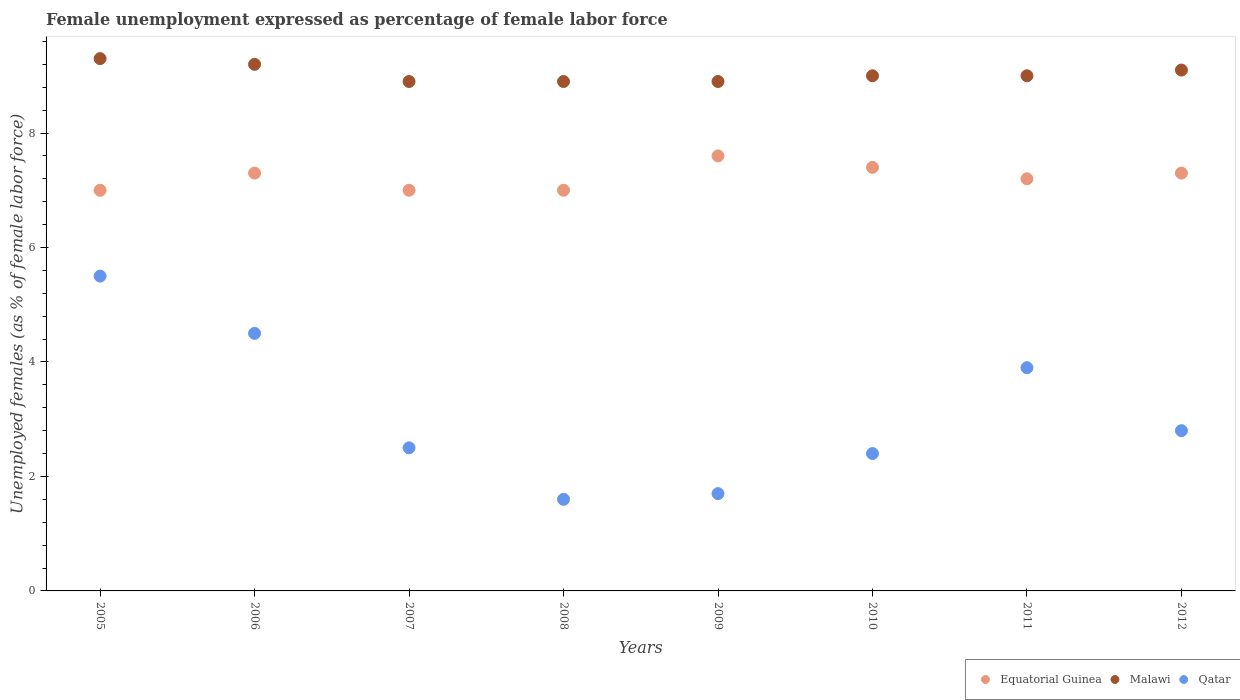How many different coloured dotlines are there?
Your answer should be compact. 3. What is the unemployment in females in in Malawi in 2011?
Keep it short and to the point. 9. Across all years, what is the maximum unemployment in females in in Malawi?
Keep it short and to the point. 9.3. Across all years, what is the minimum unemployment in females in in Malawi?
Make the answer very short. 8.9. In which year was the unemployment in females in in Malawi maximum?
Offer a terse response. 2005. What is the total unemployment in females in in Qatar in the graph?
Your answer should be compact. 24.9. What is the difference between the unemployment in females in in Equatorial Guinea in 2009 and that in 2011?
Offer a very short reply. 0.4. What is the difference between the unemployment in females in in Equatorial Guinea in 2007 and the unemployment in females in in Malawi in 2009?
Offer a very short reply. -1.9. What is the average unemployment in females in in Qatar per year?
Make the answer very short. 3.11. In the year 2010, what is the difference between the unemployment in females in in Equatorial Guinea and unemployment in females in in Qatar?
Your answer should be compact. 5. What is the ratio of the unemployment in females in in Qatar in 2006 to that in 2012?
Give a very brief answer. 1.61. Is the unemployment in females in in Malawi in 2005 less than that in 2010?
Your answer should be compact. No. Is the difference between the unemployment in females in in Equatorial Guinea in 2009 and 2010 greater than the difference between the unemployment in females in in Qatar in 2009 and 2010?
Provide a short and direct response. Yes. What is the difference between the highest and the second highest unemployment in females in in Equatorial Guinea?
Your response must be concise. 0.2. What is the difference between the highest and the lowest unemployment in females in in Equatorial Guinea?
Provide a succinct answer. 0.6. In how many years, is the unemployment in females in in Qatar greater than the average unemployment in females in in Qatar taken over all years?
Your answer should be compact. 3. Is it the case that in every year, the sum of the unemployment in females in in Equatorial Guinea and unemployment in females in in Qatar  is greater than the unemployment in females in in Malawi?
Provide a short and direct response. No. Does the unemployment in females in in Qatar monotonically increase over the years?
Provide a short and direct response. No. What is the difference between two consecutive major ticks on the Y-axis?
Provide a succinct answer. 2. Are the values on the major ticks of Y-axis written in scientific E-notation?
Offer a very short reply. No. How are the legend labels stacked?
Ensure brevity in your answer.  Horizontal. What is the title of the graph?
Offer a terse response. Female unemployment expressed as percentage of female labor force. Does "Ghana" appear as one of the legend labels in the graph?
Make the answer very short. No. What is the label or title of the Y-axis?
Your answer should be very brief. Unemployed females (as % of female labor force). What is the Unemployed females (as % of female labor force) in Malawi in 2005?
Give a very brief answer. 9.3. What is the Unemployed females (as % of female labor force) in Qatar in 2005?
Offer a terse response. 5.5. What is the Unemployed females (as % of female labor force) of Equatorial Guinea in 2006?
Offer a very short reply. 7.3. What is the Unemployed females (as % of female labor force) in Malawi in 2006?
Your answer should be very brief. 9.2. What is the Unemployed females (as % of female labor force) of Qatar in 2006?
Ensure brevity in your answer.  4.5. What is the Unemployed females (as % of female labor force) in Malawi in 2007?
Your response must be concise. 8.9. What is the Unemployed females (as % of female labor force) of Malawi in 2008?
Give a very brief answer. 8.9. What is the Unemployed females (as % of female labor force) in Qatar in 2008?
Keep it short and to the point. 1.6. What is the Unemployed females (as % of female labor force) in Equatorial Guinea in 2009?
Ensure brevity in your answer.  7.6. What is the Unemployed females (as % of female labor force) of Malawi in 2009?
Provide a succinct answer. 8.9. What is the Unemployed females (as % of female labor force) in Qatar in 2009?
Keep it short and to the point. 1.7. What is the Unemployed females (as % of female labor force) of Equatorial Guinea in 2010?
Your answer should be compact. 7.4. What is the Unemployed females (as % of female labor force) in Malawi in 2010?
Offer a terse response. 9. What is the Unemployed females (as % of female labor force) in Qatar in 2010?
Your response must be concise. 2.4. What is the Unemployed females (as % of female labor force) of Equatorial Guinea in 2011?
Provide a short and direct response. 7.2. What is the Unemployed females (as % of female labor force) in Qatar in 2011?
Make the answer very short. 3.9. What is the Unemployed females (as % of female labor force) of Equatorial Guinea in 2012?
Your answer should be very brief. 7.3. What is the Unemployed females (as % of female labor force) of Malawi in 2012?
Keep it short and to the point. 9.1. What is the Unemployed females (as % of female labor force) in Qatar in 2012?
Give a very brief answer. 2.8. Across all years, what is the maximum Unemployed females (as % of female labor force) of Equatorial Guinea?
Keep it short and to the point. 7.6. Across all years, what is the maximum Unemployed females (as % of female labor force) in Malawi?
Provide a short and direct response. 9.3. Across all years, what is the maximum Unemployed females (as % of female labor force) in Qatar?
Ensure brevity in your answer.  5.5. Across all years, what is the minimum Unemployed females (as % of female labor force) of Equatorial Guinea?
Provide a succinct answer. 7. Across all years, what is the minimum Unemployed females (as % of female labor force) of Malawi?
Ensure brevity in your answer.  8.9. Across all years, what is the minimum Unemployed females (as % of female labor force) of Qatar?
Provide a short and direct response. 1.6. What is the total Unemployed females (as % of female labor force) of Equatorial Guinea in the graph?
Make the answer very short. 57.8. What is the total Unemployed females (as % of female labor force) in Malawi in the graph?
Your answer should be very brief. 72.3. What is the total Unemployed females (as % of female labor force) of Qatar in the graph?
Ensure brevity in your answer.  24.9. What is the difference between the Unemployed females (as % of female labor force) of Equatorial Guinea in 2005 and that in 2006?
Your answer should be very brief. -0.3. What is the difference between the Unemployed females (as % of female labor force) in Equatorial Guinea in 2005 and that in 2007?
Your response must be concise. 0. What is the difference between the Unemployed females (as % of female labor force) of Malawi in 2005 and that in 2007?
Provide a short and direct response. 0.4. What is the difference between the Unemployed females (as % of female labor force) of Qatar in 2005 and that in 2007?
Your answer should be compact. 3. What is the difference between the Unemployed females (as % of female labor force) in Qatar in 2005 and that in 2009?
Offer a very short reply. 3.8. What is the difference between the Unemployed females (as % of female labor force) of Equatorial Guinea in 2005 and that in 2010?
Provide a succinct answer. -0.4. What is the difference between the Unemployed females (as % of female labor force) in Malawi in 2005 and that in 2010?
Provide a succinct answer. 0.3. What is the difference between the Unemployed females (as % of female labor force) in Malawi in 2005 and that in 2011?
Offer a terse response. 0.3. What is the difference between the Unemployed females (as % of female labor force) in Qatar in 2005 and that in 2011?
Give a very brief answer. 1.6. What is the difference between the Unemployed females (as % of female labor force) in Equatorial Guinea in 2005 and that in 2012?
Give a very brief answer. -0.3. What is the difference between the Unemployed females (as % of female labor force) of Malawi in 2005 and that in 2012?
Provide a succinct answer. 0.2. What is the difference between the Unemployed females (as % of female labor force) of Qatar in 2005 and that in 2012?
Your answer should be compact. 2.7. What is the difference between the Unemployed females (as % of female labor force) in Malawi in 2006 and that in 2008?
Your response must be concise. 0.3. What is the difference between the Unemployed females (as % of female labor force) in Qatar in 2006 and that in 2008?
Ensure brevity in your answer.  2.9. What is the difference between the Unemployed females (as % of female labor force) of Malawi in 2006 and that in 2009?
Offer a terse response. 0.3. What is the difference between the Unemployed females (as % of female labor force) in Equatorial Guinea in 2006 and that in 2010?
Make the answer very short. -0.1. What is the difference between the Unemployed females (as % of female labor force) of Qatar in 2006 and that in 2010?
Offer a very short reply. 2.1. What is the difference between the Unemployed females (as % of female labor force) of Equatorial Guinea in 2006 and that in 2011?
Offer a very short reply. 0.1. What is the difference between the Unemployed females (as % of female labor force) in Malawi in 2006 and that in 2011?
Provide a short and direct response. 0.2. What is the difference between the Unemployed females (as % of female labor force) in Equatorial Guinea in 2006 and that in 2012?
Your answer should be compact. 0. What is the difference between the Unemployed females (as % of female labor force) in Malawi in 2006 and that in 2012?
Offer a very short reply. 0.1. What is the difference between the Unemployed females (as % of female labor force) in Qatar in 2006 and that in 2012?
Provide a short and direct response. 1.7. What is the difference between the Unemployed females (as % of female labor force) of Equatorial Guinea in 2007 and that in 2008?
Offer a very short reply. 0. What is the difference between the Unemployed females (as % of female labor force) in Malawi in 2007 and that in 2009?
Offer a very short reply. 0. What is the difference between the Unemployed females (as % of female labor force) of Qatar in 2007 and that in 2009?
Your answer should be compact. 0.8. What is the difference between the Unemployed females (as % of female labor force) in Equatorial Guinea in 2007 and that in 2010?
Provide a short and direct response. -0.4. What is the difference between the Unemployed females (as % of female labor force) of Malawi in 2007 and that in 2010?
Your answer should be compact. -0.1. What is the difference between the Unemployed females (as % of female labor force) in Qatar in 2007 and that in 2010?
Keep it short and to the point. 0.1. What is the difference between the Unemployed females (as % of female labor force) in Qatar in 2008 and that in 2009?
Provide a succinct answer. -0.1. What is the difference between the Unemployed females (as % of female labor force) of Equatorial Guinea in 2008 and that in 2010?
Make the answer very short. -0.4. What is the difference between the Unemployed females (as % of female labor force) of Malawi in 2008 and that in 2010?
Keep it short and to the point. -0.1. What is the difference between the Unemployed females (as % of female labor force) in Qatar in 2008 and that in 2010?
Provide a succinct answer. -0.8. What is the difference between the Unemployed females (as % of female labor force) in Equatorial Guinea in 2008 and that in 2011?
Ensure brevity in your answer.  -0.2. What is the difference between the Unemployed females (as % of female labor force) in Equatorial Guinea in 2008 and that in 2012?
Your answer should be compact. -0.3. What is the difference between the Unemployed females (as % of female labor force) of Malawi in 2008 and that in 2012?
Offer a terse response. -0.2. What is the difference between the Unemployed females (as % of female labor force) in Qatar in 2008 and that in 2012?
Offer a terse response. -1.2. What is the difference between the Unemployed females (as % of female labor force) in Malawi in 2009 and that in 2011?
Your response must be concise. -0.1. What is the difference between the Unemployed females (as % of female labor force) of Equatorial Guinea in 2009 and that in 2012?
Provide a succinct answer. 0.3. What is the difference between the Unemployed females (as % of female labor force) in Malawi in 2009 and that in 2012?
Give a very brief answer. -0.2. What is the difference between the Unemployed females (as % of female labor force) in Qatar in 2009 and that in 2012?
Give a very brief answer. -1.1. What is the difference between the Unemployed females (as % of female labor force) in Equatorial Guinea in 2010 and that in 2011?
Offer a very short reply. 0.2. What is the difference between the Unemployed females (as % of female labor force) of Equatorial Guinea in 2010 and that in 2012?
Keep it short and to the point. 0.1. What is the difference between the Unemployed females (as % of female labor force) in Qatar in 2010 and that in 2012?
Your response must be concise. -0.4. What is the difference between the Unemployed females (as % of female labor force) of Equatorial Guinea in 2011 and that in 2012?
Provide a succinct answer. -0.1. What is the difference between the Unemployed females (as % of female labor force) in Malawi in 2005 and the Unemployed females (as % of female labor force) in Qatar in 2006?
Your answer should be compact. 4.8. What is the difference between the Unemployed females (as % of female labor force) of Equatorial Guinea in 2005 and the Unemployed females (as % of female labor force) of Malawi in 2007?
Give a very brief answer. -1.9. What is the difference between the Unemployed females (as % of female labor force) of Malawi in 2005 and the Unemployed females (as % of female labor force) of Qatar in 2007?
Your response must be concise. 6.8. What is the difference between the Unemployed females (as % of female labor force) of Equatorial Guinea in 2005 and the Unemployed females (as % of female labor force) of Qatar in 2008?
Keep it short and to the point. 5.4. What is the difference between the Unemployed females (as % of female labor force) of Malawi in 2005 and the Unemployed females (as % of female labor force) of Qatar in 2008?
Provide a succinct answer. 7.7. What is the difference between the Unemployed females (as % of female labor force) in Malawi in 2005 and the Unemployed females (as % of female labor force) in Qatar in 2009?
Provide a short and direct response. 7.6. What is the difference between the Unemployed females (as % of female labor force) of Equatorial Guinea in 2005 and the Unemployed females (as % of female labor force) of Qatar in 2010?
Ensure brevity in your answer.  4.6. What is the difference between the Unemployed females (as % of female labor force) in Equatorial Guinea in 2005 and the Unemployed females (as % of female labor force) in Qatar in 2011?
Your answer should be very brief. 3.1. What is the difference between the Unemployed females (as % of female labor force) of Malawi in 2005 and the Unemployed females (as % of female labor force) of Qatar in 2011?
Give a very brief answer. 5.4. What is the difference between the Unemployed females (as % of female labor force) of Equatorial Guinea in 2005 and the Unemployed females (as % of female labor force) of Qatar in 2012?
Keep it short and to the point. 4.2. What is the difference between the Unemployed females (as % of female labor force) of Malawi in 2006 and the Unemployed females (as % of female labor force) of Qatar in 2007?
Give a very brief answer. 6.7. What is the difference between the Unemployed females (as % of female labor force) in Equatorial Guinea in 2006 and the Unemployed females (as % of female labor force) in Malawi in 2009?
Ensure brevity in your answer.  -1.6. What is the difference between the Unemployed females (as % of female labor force) of Equatorial Guinea in 2006 and the Unemployed females (as % of female labor force) of Qatar in 2009?
Your response must be concise. 5.6. What is the difference between the Unemployed females (as % of female labor force) of Equatorial Guinea in 2006 and the Unemployed females (as % of female labor force) of Malawi in 2010?
Your answer should be very brief. -1.7. What is the difference between the Unemployed females (as % of female labor force) in Equatorial Guinea in 2006 and the Unemployed females (as % of female labor force) in Qatar in 2010?
Provide a succinct answer. 4.9. What is the difference between the Unemployed females (as % of female labor force) of Malawi in 2006 and the Unemployed females (as % of female labor force) of Qatar in 2010?
Provide a succinct answer. 6.8. What is the difference between the Unemployed females (as % of female labor force) of Equatorial Guinea in 2006 and the Unemployed females (as % of female labor force) of Qatar in 2011?
Keep it short and to the point. 3.4. What is the difference between the Unemployed females (as % of female labor force) of Equatorial Guinea in 2006 and the Unemployed females (as % of female labor force) of Qatar in 2012?
Provide a succinct answer. 4.5. What is the difference between the Unemployed females (as % of female labor force) in Malawi in 2006 and the Unemployed females (as % of female labor force) in Qatar in 2012?
Provide a short and direct response. 6.4. What is the difference between the Unemployed females (as % of female labor force) of Equatorial Guinea in 2007 and the Unemployed females (as % of female labor force) of Qatar in 2008?
Your answer should be compact. 5.4. What is the difference between the Unemployed females (as % of female labor force) in Malawi in 2007 and the Unemployed females (as % of female labor force) in Qatar in 2009?
Keep it short and to the point. 7.2. What is the difference between the Unemployed females (as % of female labor force) of Equatorial Guinea in 2007 and the Unemployed females (as % of female labor force) of Malawi in 2010?
Give a very brief answer. -2. What is the difference between the Unemployed females (as % of female labor force) in Equatorial Guinea in 2007 and the Unemployed females (as % of female labor force) in Qatar in 2010?
Ensure brevity in your answer.  4.6. What is the difference between the Unemployed females (as % of female labor force) in Malawi in 2007 and the Unemployed females (as % of female labor force) in Qatar in 2010?
Your answer should be very brief. 6.5. What is the difference between the Unemployed females (as % of female labor force) in Equatorial Guinea in 2007 and the Unemployed females (as % of female labor force) in Malawi in 2011?
Make the answer very short. -2. What is the difference between the Unemployed females (as % of female labor force) in Equatorial Guinea in 2007 and the Unemployed females (as % of female labor force) in Qatar in 2011?
Give a very brief answer. 3.1. What is the difference between the Unemployed females (as % of female labor force) of Malawi in 2007 and the Unemployed females (as % of female labor force) of Qatar in 2011?
Offer a terse response. 5. What is the difference between the Unemployed females (as % of female labor force) in Equatorial Guinea in 2008 and the Unemployed females (as % of female labor force) in Malawi in 2009?
Your answer should be very brief. -1.9. What is the difference between the Unemployed females (as % of female labor force) in Equatorial Guinea in 2008 and the Unemployed females (as % of female labor force) in Qatar in 2009?
Your answer should be very brief. 5.3. What is the difference between the Unemployed females (as % of female labor force) of Malawi in 2008 and the Unemployed females (as % of female labor force) of Qatar in 2009?
Your answer should be very brief. 7.2. What is the difference between the Unemployed females (as % of female labor force) of Equatorial Guinea in 2008 and the Unemployed females (as % of female labor force) of Malawi in 2010?
Your answer should be compact. -2. What is the difference between the Unemployed females (as % of female labor force) of Equatorial Guinea in 2008 and the Unemployed females (as % of female labor force) of Qatar in 2010?
Your answer should be compact. 4.6. What is the difference between the Unemployed females (as % of female labor force) of Equatorial Guinea in 2008 and the Unemployed females (as % of female labor force) of Malawi in 2012?
Offer a terse response. -2.1. What is the difference between the Unemployed females (as % of female labor force) of Malawi in 2008 and the Unemployed females (as % of female labor force) of Qatar in 2012?
Ensure brevity in your answer.  6.1. What is the difference between the Unemployed females (as % of female labor force) of Equatorial Guinea in 2009 and the Unemployed females (as % of female labor force) of Malawi in 2010?
Your answer should be very brief. -1.4. What is the difference between the Unemployed females (as % of female labor force) of Equatorial Guinea in 2009 and the Unemployed females (as % of female labor force) of Qatar in 2010?
Give a very brief answer. 5.2. What is the difference between the Unemployed females (as % of female labor force) in Malawi in 2009 and the Unemployed females (as % of female labor force) in Qatar in 2010?
Provide a short and direct response. 6.5. What is the difference between the Unemployed females (as % of female labor force) of Equatorial Guinea in 2009 and the Unemployed females (as % of female labor force) of Malawi in 2011?
Give a very brief answer. -1.4. What is the difference between the Unemployed females (as % of female labor force) in Equatorial Guinea in 2009 and the Unemployed females (as % of female labor force) in Qatar in 2011?
Make the answer very short. 3.7. What is the difference between the Unemployed females (as % of female labor force) of Equatorial Guinea in 2009 and the Unemployed females (as % of female labor force) of Malawi in 2012?
Give a very brief answer. -1.5. What is the difference between the Unemployed females (as % of female labor force) of Malawi in 2010 and the Unemployed females (as % of female labor force) of Qatar in 2011?
Give a very brief answer. 5.1. What is the difference between the Unemployed females (as % of female labor force) of Equatorial Guinea in 2010 and the Unemployed females (as % of female labor force) of Malawi in 2012?
Ensure brevity in your answer.  -1.7. What is the difference between the Unemployed females (as % of female labor force) in Malawi in 2010 and the Unemployed females (as % of female labor force) in Qatar in 2012?
Ensure brevity in your answer.  6.2. What is the difference between the Unemployed females (as % of female labor force) of Equatorial Guinea in 2011 and the Unemployed females (as % of female labor force) of Malawi in 2012?
Provide a succinct answer. -1.9. What is the difference between the Unemployed females (as % of female labor force) of Malawi in 2011 and the Unemployed females (as % of female labor force) of Qatar in 2012?
Provide a succinct answer. 6.2. What is the average Unemployed females (as % of female labor force) in Equatorial Guinea per year?
Your answer should be compact. 7.22. What is the average Unemployed females (as % of female labor force) of Malawi per year?
Ensure brevity in your answer.  9.04. What is the average Unemployed females (as % of female labor force) of Qatar per year?
Provide a succinct answer. 3.11. In the year 2005, what is the difference between the Unemployed females (as % of female labor force) of Equatorial Guinea and Unemployed females (as % of female labor force) of Malawi?
Offer a very short reply. -2.3. In the year 2007, what is the difference between the Unemployed females (as % of female labor force) of Equatorial Guinea and Unemployed females (as % of female labor force) of Malawi?
Provide a succinct answer. -1.9. In the year 2008, what is the difference between the Unemployed females (as % of female labor force) in Malawi and Unemployed females (as % of female labor force) in Qatar?
Offer a terse response. 7.3. In the year 2009, what is the difference between the Unemployed females (as % of female labor force) in Malawi and Unemployed females (as % of female labor force) in Qatar?
Make the answer very short. 7.2. In the year 2010, what is the difference between the Unemployed females (as % of female labor force) of Equatorial Guinea and Unemployed females (as % of female labor force) of Qatar?
Provide a succinct answer. 5. In the year 2010, what is the difference between the Unemployed females (as % of female labor force) in Malawi and Unemployed females (as % of female labor force) in Qatar?
Give a very brief answer. 6.6. In the year 2011, what is the difference between the Unemployed females (as % of female labor force) of Malawi and Unemployed females (as % of female labor force) of Qatar?
Provide a short and direct response. 5.1. In the year 2012, what is the difference between the Unemployed females (as % of female labor force) in Equatorial Guinea and Unemployed females (as % of female labor force) in Malawi?
Ensure brevity in your answer.  -1.8. What is the ratio of the Unemployed females (as % of female labor force) in Equatorial Guinea in 2005 to that in 2006?
Keep it short and to the point. 0.96. What is the ratio of the Unemployed females (as % of female labor force) of Malawi in 2005 to that in 2006?
Make the answer very short. 1.01. What is the ratio of the Unemployed females (as % of female labor force) in Qatar in 2005 to that in 2006?
Provide a short and direct response. 1.22. What is the ratio of the Unemployed females (as % of female labor force) in Equatorial Guinea in 2005 to that in 2007?
Your answer should be very brief. 1. What is the ratio of the Unemployed females (as % of female labor force) of Malawi in 2005 to that in 2007?
Give a very brief answer. 1.04. What is the ratio of the Unemployed females (as % of female labor force) of Equatorial Guinea in 2005 to that in 2008?
Offer a terse response. 1. What is the ratio of the Unemployed females (as % of female labor force) in Malawi in 2005 to that in 2008?
Your response must be concise. 1.04. What is the ratio of the Unemployed females (as % of female labor force) in Qatar in 2005 to that in 2008?
Ensure brevity in your answer.  3.44. What is the ratio of the Unemployed females (as % of female labor force) in Equatorial Guinea in 2005 to that in 2009?
Offer a terse response. 0.92. What is the ratio of the Unemployed females (as % of female labor force) in Malawi in 2005 to that in 2009?
Keep it short and to the point. 1.04. What is the ratio of the Unemployed females (as % of female labor force) of Qatar in 2005 to that in 2009?
Your answer should be compact. 3.24. What is the ratio of the Unemployed females (as % of female labor force) in Equatorial Guinea in 2005 to that in 2010?
Ensure brevity in your answer.  0.95. What is the ratio of the Unemployed females (as % of female labor force) in Qatar in 2005 to that in 2010?
Your response must be concise. 2.29. What is the ratio of the Unemployed females (as % of female labor force) of Equatorial Guinea in 2005 to that in 2011?
Ensure brevity in your answer.  0.97. What is the ratio of the Unemployed females (as % of female labor force) of Malawi in 2005 to that in 2011?
Make the answer very short. 1.03. What is the ratio of the Unemployed females (as % of female labor force) in Qatar in 2005 to that in 2011?
Offer a terse response. 1.41. What is the ratio of the Unemployed females (as % of female labor force) in Equatorial Guinea in 2005 to that in 2012?
Make the answer very short. 0.96. What is the ratio of the Unemployed females (as % of female labor force) in Qatar in 2005 to that in 2012?
Give a very brief answer. 1.96. What is the ratio of the Unemployed females (as % of female labor force) in Equatorial Guinea in 2006 to that in 2007?
Provide a short and direct response. 1.04. What is the ratio of the Unemployed females (as % of female labor force) in Malawi in 2006 to that in 2007?
Make the answer very short. 1.03. What is the ratio of the Unemployed females (as % of female labor force) of Qatar in 2006 to that in 2007?
Ensure brevity in your answer.  1.8. What is the ratio of the Unemployed females (as % of female labor force) in Equatorial Guinea in 2006 to that in 2008?
Give a very brief answer. 1.04. What is the ratio of the Unemployed females (as % of female labor force) in Malawi in 2006 to that in 2008?
Provide a succinct answer. 1.03. What is the ratio of the Unemployed females (as % of female labor force) of Qatar in 2006 to that in 2008?
Provide a succinct answer. 2.81. What is the ratio of the Unemployed females (as % of female labor force) of Equatorial Guinea in 2006 to that in 2009?
Make the answer very short. 0.96. What is the ratio of the Unemployed females (as % of female labor force) in Malawi in 2006 to that in 2009?
Make the answer very short. 1.03. What is the ratio of the Unemployed females (as % of female labor force) of Qatar in 2006 to that in 2009?
Offer a very short reply. 2.65. What is the ratio of the Unemployed females (as % of female labor force) of Equatorial Guinea in 2006 to that in 2010?
Your response must be concise. 0.99. What is the ratio of the Unemployed females (as % of female labor force) of Malawi in 2006 to that in 2010?
Provide a succinct answer. 1.02. What is the ratio of the Unemployed females (as % of female labor force) in Qatar in 2006 to that in 2010?
Your response must be concise. 1.88. What is the ratio of the Unemployed females (as % of female labor force) of Equatorial Guinea in 2006 to that in 2011?
Your answer should be compact. 1.01. What is the ratio of the Unemployed females (as % of female labor force) in Malawi in 2006 to that in 2011?
Make the answer very short. 1.02. What is the ratio of the Unemployed females (as % of female labor force) in Qatar in 2006 to that in 2011?
Provide a succinct answer. 1.15. What is the ratio of the Unemployed females (as % of female labor force) in Equatorial Guinea in 2006 to that in 2012?
Provide a succinct answer. 1. What is the ratio of the Unemployed females (as % of female labor force) in Qatar in 2006 to that in 2012?
Your answer should be compact. 1.61. What is the ratio of the Unemployed females (as % of female labor force) of Equatorial Guinea in 2007 to that in 2008?
Your response must be concise. 1. What is the ratio of the Unemployed females (as % of female labor force) of Qatar in 2007 to that in 2008?
Ensure brevity in your answer.  1.56. What is the ratio of the Unemployed females (as % of female labor force) of Equatorial Guinea in 2007 to that in 2009?
Offer a terse response. 0.92. What is the ratio of the Unemployed females (as % of female labor force) in Qatar in 2007 to that in 2009?
Ensure brevity in your answer.  1.47. What is the ratio of the Unemployed females (as % of female labor force) of Equatorial Guinea in 2007 to that in 2010?
Offer a terse response. 0.95. What is the ratio of the Unemployed females (as % of female labor force) in Malawi in 2007 to that in 2010?
Provide a succinct answer. 0.99. What is the ratio of the Unemployed females (as % of female labor force) of Qatar in 2007 to that in 2010?
Make the answer very short. 1.04. What is the ratio of the Unemployed females (as % of female labor force) of Equatorial Guinea in 2007 to that in 2011?
Provide a succinct answer. 0.97. What is the ratio of the Unemployed females (as % of female labor force) in Malawi in 2007 to that in 2011?
Your answer should be very brief. 0.99. What is the ratio of the Unemployed females (as % of female labor force) of Qatar in 2007 to that in 2011?
Your answer should be very brief. 0.64. What is the ratio of the Unemployed females (as % of female labor force) in Equatorial Guinea in 2007 to that in 2012?
Give a very brief answer. 0.96. What is the ratio of the Unemployed females (as % of female labor force) in Malawi in 2007 to that in 2012?
Offer a very short reply. 0.98. What is the ratio of the Unemployed females (as % of female labor force) in Qatar in 2007 to that in 2012?
Your answer should be very brief. 0.89. What is the ratio of the Unemployed females (as % of female labor force) of Equatorial Guinea in 2008 to that in 2009?
Keep it short and to the point. 0.92. What is the ratio of the Unemployed females (as % of female labor force) in Qatar in 2008 to that in 2009?
Give a very brief answer. 0.94. What is the ratio of the Unemployed females (as % of female labor force) in Equatorial Guinea in 2008 to that in 2010?
Provide a succinct answer. 0.95. What is the ratio of the Unemployed females (as % of female labor force) of Malawi in 2008 to that in 2010?
Make the answer very short. 0.99. What is the ratio of the Unemployed females (as % of female labor force) of Qatar in 2008 to that in 2010?
Provide a short and direct response. 0.67. What is the ratio of the Unemployed females (as % of female labor force) in Equatorial Guinea in 2008 to that in 2011?
Offer a very short reply. 0.97. What is the ratio of the Unemployed females (as % of female labor force) in Malawi in 2008 to that in 2011?
Give a very brief answer. 0.99. What is the ratio of the Unemployed females (as % of female labor force) in Qatar in 2008 to that in 2011?
Your answer should be very brief. 0.41. What is the ratio of the Unemployed females (as % of female labor force) in Equatorial Guinea in 2008 to that in 2012?
Keep it short and to the point. 0.96. What is the ratio of the Unemployed females (as % of female labor force) in Malawi in 2008 to that in 2012?
Your response must be concise. 0.98. What is the ratio of the Unemployed females (as % of female labor force) in Equatorial Guinea in 2009 to that in 2010?
Give a very brief answer. 1.03. What is the ratio of the Unemployed females (as % of female labor force) in Malawi in 2009 to that in 2010?
Your answer should be compact. 0.99. What is the ratio of the Unemployed females (as % of female labor force) in Qatar in 2009 to that in 2010?
Your response must be concise. 0.71. What is the ratio of the Unemployed females (as % of female labor force) in Equatorial Guinea in 2009 to that in 2011?
Make the answer very short. 1.06. What is the ratio of the Unemployed females (as % of female labor force) of Malawi in 2009 to that in 2011?
Your response must be concise. 0.99. What is the ratio of the Unemployed females (as % of female labor force) in Qatar in 2009 to that in 2011?
Your answer should be very brief. 0.44. What is the ratio of the Unemployed females (as % of female labor force) of Equatorial Guinea in 2009 to that in 2012?
Your response must be concise. 1.04. What is the ratio of the Unemployed females (as % of female labor force) in Malawi in 2009 to that in 2012?
Your response must be concise. 0.98. What is the ratio of the Unemployed females (as % of female labor force) of Qatar in 2009 to that in 2012?
Your answer should be compact. 0.61. What is the ratio of the Unemployed females (as % of female labor force) in Equatorial Guinea in 2010 to that in 2011?
Offer a terse response. 1.03. What is the ratio of the Unemployed females (as % of female labor force) in Qatar in 2010 to that in 2011?
Make the answer very short. 0.62. What is the ratio of the Unemployed females (as % of female labor force) in Equatorial Guinea in 2010 to that in 2012?
Ensure brevity in your answer.  1.01. What is the ratio of the Unemployed females (as % of female labor force) of Qatar in 2010 to that in 2012?
Give a very brief answer. 0.86. What is the ratio of the Unemployed females (as % of female labor force) in Equatorial Guinea in 2011 to that in 2012?
Offer a terse response. 0.99. What is the ratio of the Unemployed females (as % of female labor force) of Malawi in 2011 to that in 2012?
Give a very brief answer. 0.99. What is the ratio of the Unemployed females (as % of female labor force) of Qatar in 2011 to that in 2012?
Your answer should be compact. 1.39. What is the difference between the highest and the second highest Unemployed females (as % of female labor force) of Equatorial Guinea?
Provide a short and direct response. 0.2. What is the difference between the highest and the lowest Unemployed females (as % of female labor force) of Equatorial Guinea?
Make the answer very short. 0.6. What is the difference between the highest and the lowest Unemployed females (as % of female labor force) of Malawi?
Your answer should be compact. 0.4. 